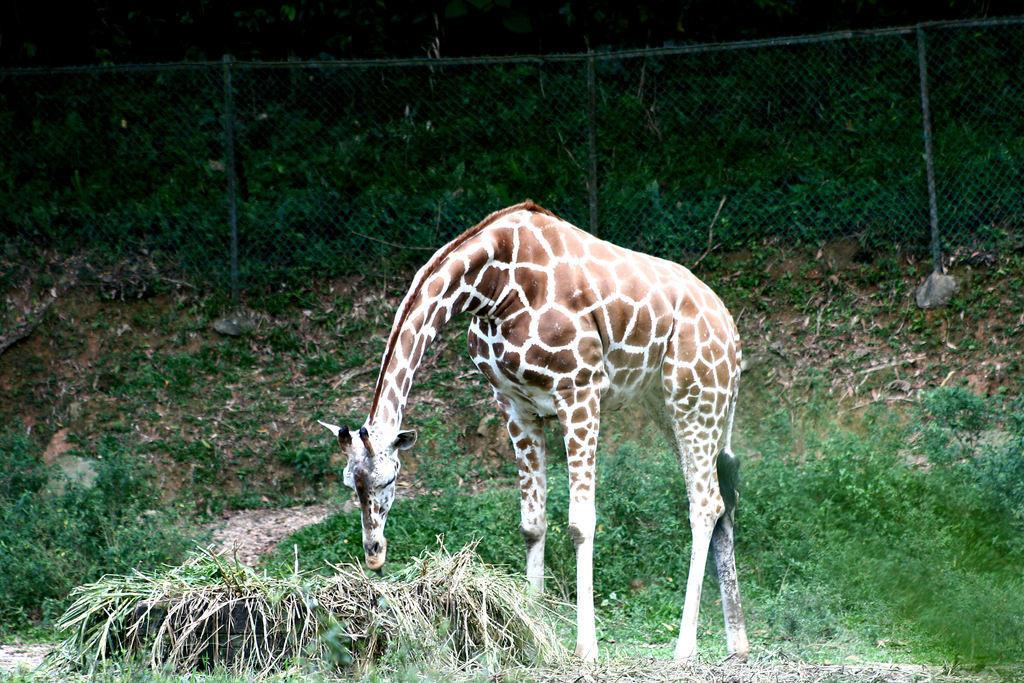How would you summarize this image in a sentence or two? In this image we can see a giraffe which is eating grass and in the background of the image there is fencing and there are some trees. 